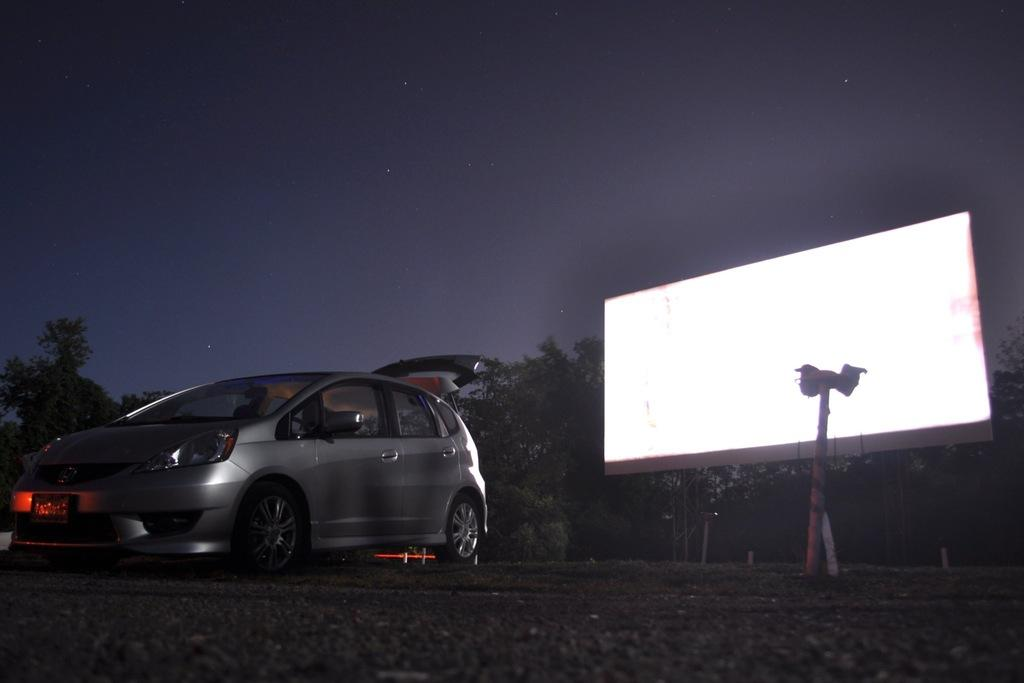What is the main subject in the image? There is a vehicle in the image. What can be seen beneath the vehicle? The ground is visible in the image. Are there any objects on the ground? Yes, there are objects on the ground. What else can be seen in the image besides the vehicle and ground? There are trees, poles, a board with some light, and the sky visible in the image. How many women are acting in the image? There are no women present in the image, and no acting is taking place. Can you describe the shaking of the objects in the image? There is no shaking of objects depicted in the image. 